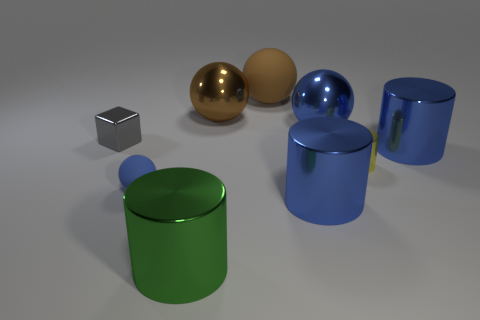What number of tiny green objects have the same shape as the brown rubber object?
Ensure brevity in your answer.  0. How many objects are either large rubber spheres or big objects to the right of the green cylinder?
Offer a very short reply. 5. There is a small cylinder; does it have the same color as the big cylinder on the left side of the large matte sphere?
Keep it short and to the point. No. There is a ball that is in front of the big brown matte thing and behind the large blue ball; how big is it?
Ensure brevity in your answer.  Large. There is a yellow thing; are there any tiny gray blocks on the left side of it?
Make the answer very short. Yes. There is a blue object that is behind the tiny gray metal cube; are there any cylinders that are left of it?
Your response must be concise. Yes. Are there an equal number of tiny spheres that are behind the tiny gray metallic thing and tiny things that are in front of the big green cylinder?
Provide a succinct answer. Yes. There is a tiny cylinder that is made of the same material as the gray object; what is its color?
Your response must be concise. Yellow. Is there a brown thing made of the same material as the green object?
Your response must be concise. Yes. How many objects are either big purple balls or large metallic balls?
Provide a succinct answer. 2. 